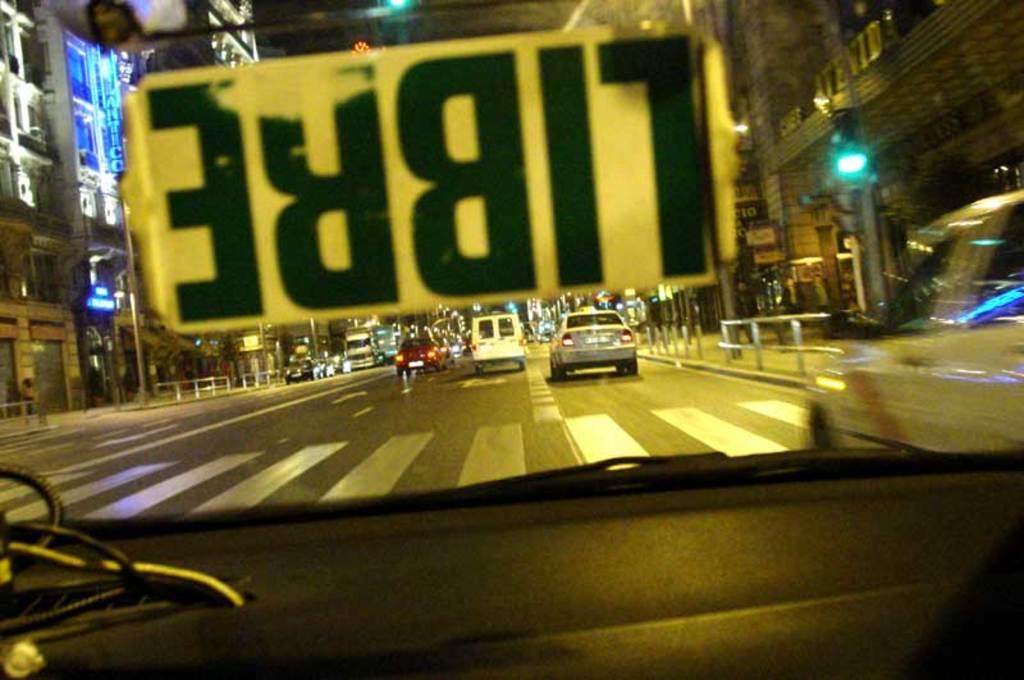What color is the text?
Offer a terse response. Answering does not require reading text in the image. 